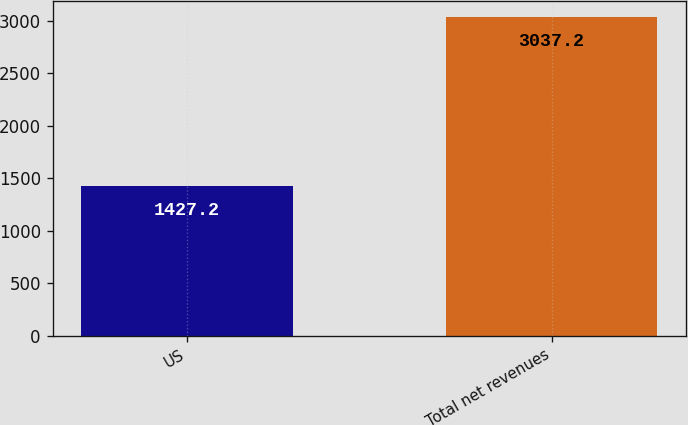Convert chart to OTSL. <chart><loc_0><loc_0><loc_500><loc_500><bar_chart><fcel>US<fcel>Total net revenues<nl><fcel>1427.2<fcel>3037.2<nl></chart> 